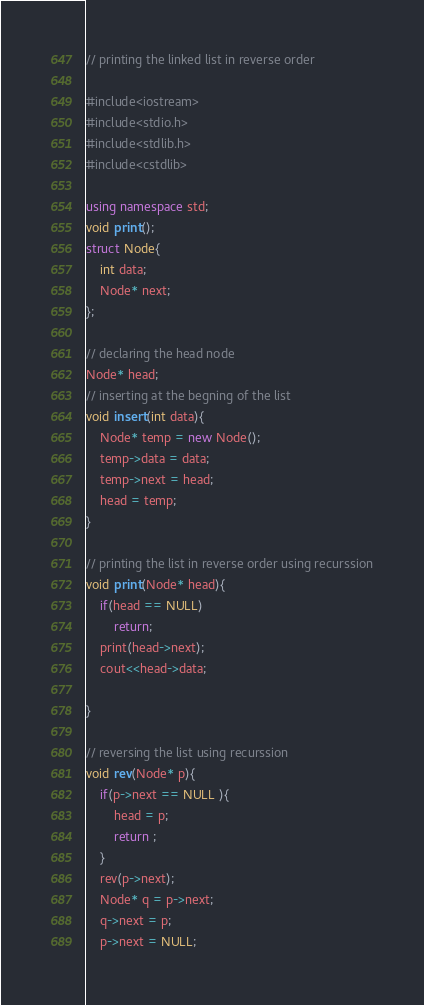Convert code to text. <code><loc_0><loc_0><loc_500><loc_500><_C++_>// printing the linked list in reverse order

#include<iostream>
#include<stdio.h>
#include<stdlib.h>
#include<cstdlib>

using namespace std;
void print();
struct Node{
	int data;
	Node* next;
};

// declaring the head node
Node* head;
// inserting at the begning of the list
void insert(int data){
	Node* temp = new Node();
	temp->data = data;
	temp->next = head;
	head = temp;
}

// printing the list in reverse order using recurssion
void print(Node* head){
	if(head == NULL)
		return;
	print(head->next);
	cout<<head->data;
	
}

// reversing the list using recurssion
void rev(Node* p){
	if(p->next == NULL ){
		head = p;
		return ;
	}
	rev(p->next);
	Node* q = p->next;
	q->next = p;
	p->next = NULL;</code> 